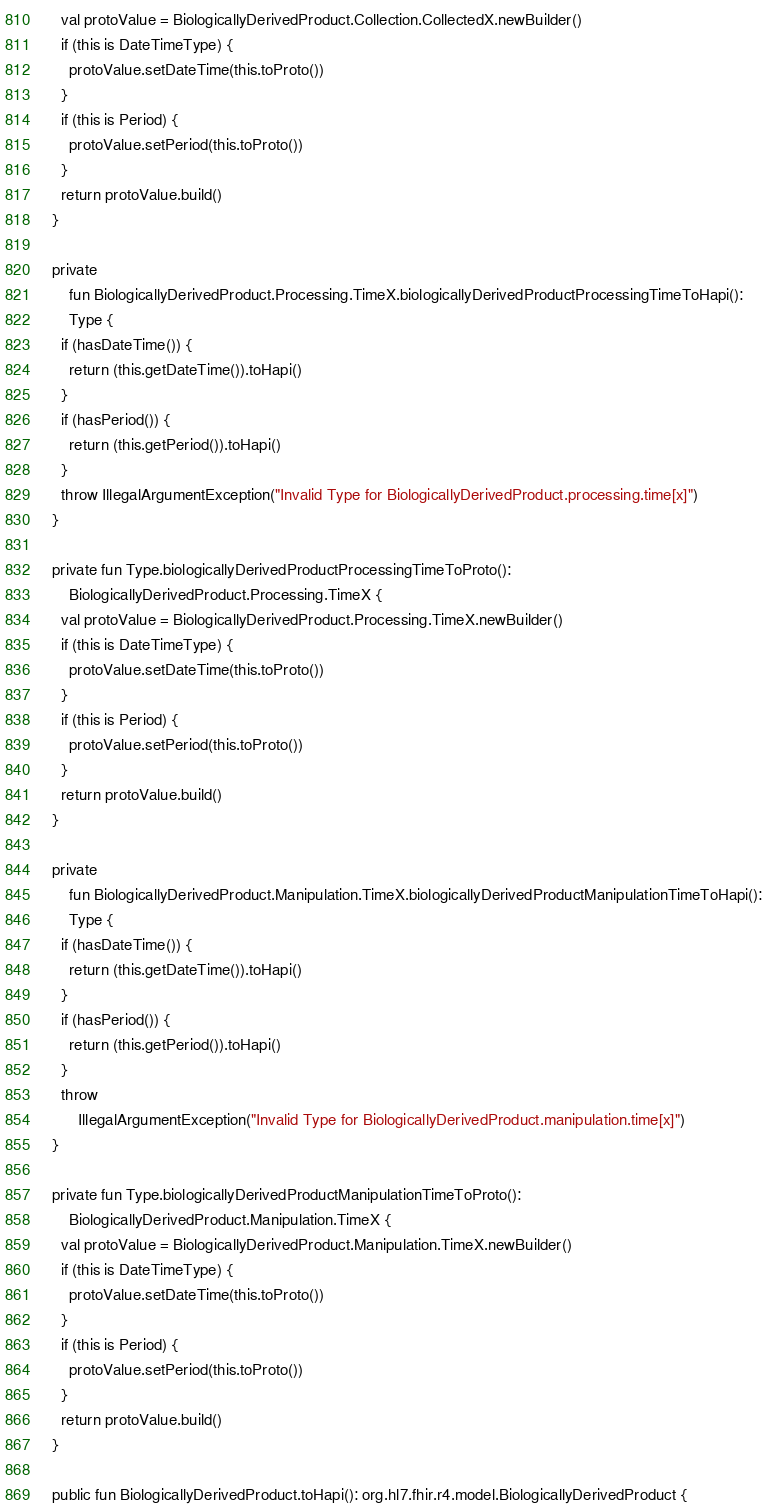<code> <loc_0><loc_0><loc_500><loc_500><_Kotlin_>    val protoValue = BiologicallyDerivedProduct.Collection.CollectedX.newBuilder()
    if (this is DateTimeType) {
      protoValue.setDateTime(this.toProto())
    }
    if (this is Period) {
      protoValue.setPeriod(this.toProto())
    }
    return protoValue.build()
  }

  private
      fun BiologicallyDerivedProduct.Processing.TimeX.biologicallyDerivedProductProcessingTimeToHapi():
      Type {
    if (hasDateTime()) {
      return (this.getDateTime()).toHapi()
    }
    if (hasPeriod()) {
      return (this.getPeriod()).toHapi()
    }
    throw IllegalArgumentException("Invalid Type for BiologicallyDerivedProduct.processing.time[x]")
  }

  private fun Type.biologicallyDerivedProductProcessingTimeToProto():
      BiologicallyDerivedProduct.Processing.TimeX {
    val protoValue = BiologicallyDerivedProduct.Processing.TimeX.newBuilder()
    if (this is DateTimeType) {
      protoValue.setDateTime(this.toProto())
    }
    if (this is Period) {
      protoValue.setPeriod(this.toProto())
    }
    return protoValue.build()
  }

  private
      fun BiologicallyDerivedProduct.Manipulation.TimeX.biologicallyDerivedProductManipulationTimeToHapi():
      Type {
    if (hasDateTime()) {
      return (this.getDateTime()).toHapi()
    }
    if (hasPeriod()) {
      return (this.getPeriod()).toHapi()
    }
    throw
        IllegalArgumentException("Invalid Type for BiologicallyDerivedProduct.manipulation.time[x]")
  }

  private fun Type.biologicallyDerivedProductManipulationTimeToProto():
      BiologicallyDerivedProduct.Manipulation.TimeX {
    val protoValue = BiologicallyDerivedProduct.Manipulation.TimeX.newBuilder()
    if (this is DateTimeType) {
      protoValue.setDateTime(this.toProto())
    }
    if (this is Period) {
      protoValue.setPeriod(this.toProto())
    }
    return protoValue.build()
  }

  public fun BiologicallyDerivedProduct.toHapi(): org.hl7.fhir.r4.model.BiologicallyDerivedProduct {</code> 